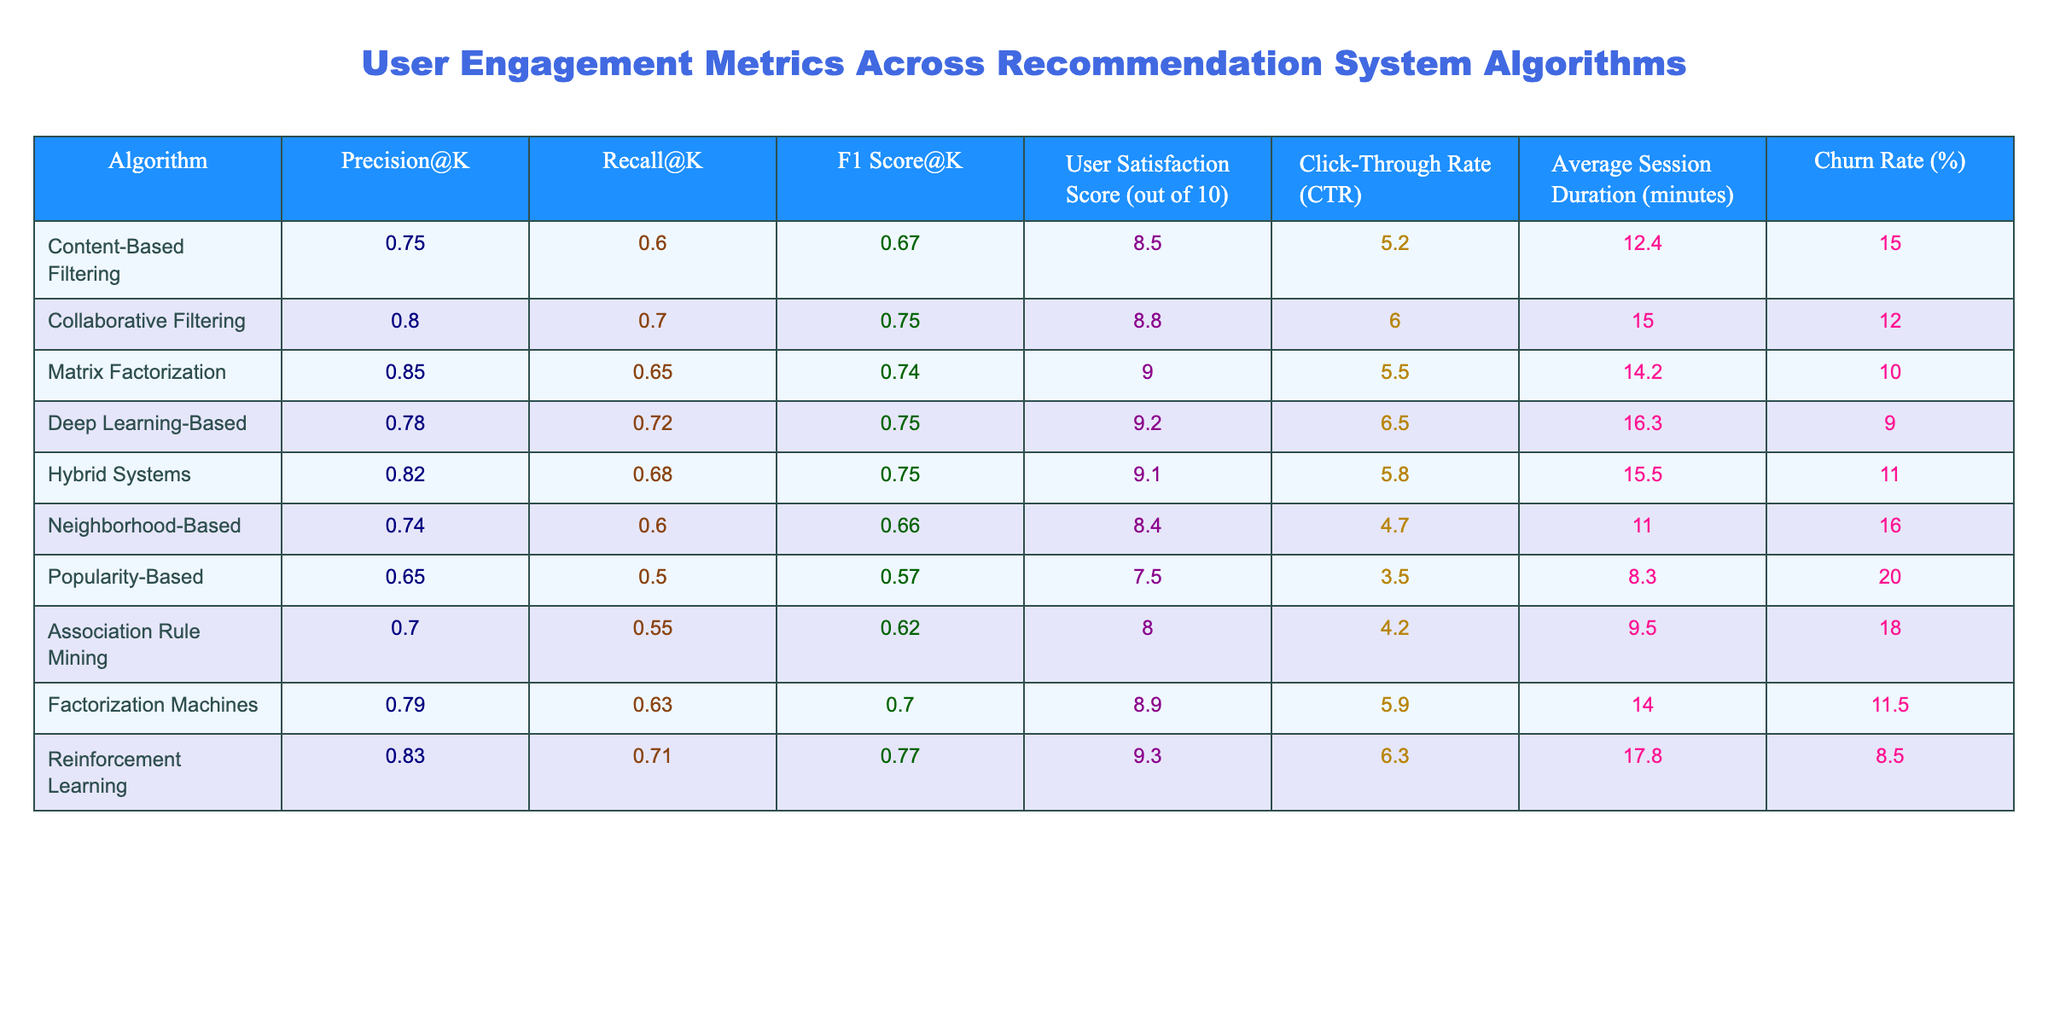What is the Precision@K of the Deep Learning-Based algorithm? The table shows that the Precision@K for the Deep Learning-Based algorithm is 0.78.
Answer: 0.78 Which algorithm has the highest Recall@K? The table indicates that the Matrix Factorization algorithm has the highest Recall@K value of 0.65.
Answer: Matrix Factorization What is the Average Session Duration for the Hybrid Systems? The table lists the Average Session Duration for Hybrid Systems as 15.5 minutes.
Answer: 15.5 minutes Which algorithm has the greatest User Satisfaction Score? Looking at the User Satisfaction Score column, the Deep Learning-Based algorithm, with a score of 9.2, has the highest value.
Answer: 9.2 What is the difference in Churn Rate between Popularity-Based and Neighborhood-Based algorithms? The Churn Rate for Popularity-Based is 20.0% and for Neighborhood-Based is 16.0%; therefore, the difference is 20.0% - 16.0% = 4.0%.
Answer: 4.0% Which two algorithms had a Recall@K greater than 0.70? The algorithms that fulfill this criterion are Collaborative Filtering (0.70) and Deep Learning-Based (0.72).
Answer: Collaborative Filtering and Deep Learning-Based What is the average User Satisfaction Score for all algorithms? To find the average, add all User Satisfaction Scores (8.5 + 8.8 + 9.0 + 9.2 + 9.1 + 8.4 + 7.5 + 8.0 + 8.9 + 9.3) and divide by the number of algorithms (10): (8.5 + 8.8 + 9.0 + 9.2 + 9.1 + 8.4 + 7.5 + 8.0 + 8.9 + 9.3) / 10 = 8.75.
Answer: 8.75 Is the Click-Through Rate higher for Hybrid Systems than for Collaborative Filtering? The Click-Through Rate for Hybrid Systems is 5.8%, while for Collaborative Filtering it's 6.0%, so Hybrid Systems have a lower Click-Through Rate.
Answer: No Which recommendation system algorithm has the lowest F1 Score@K and what is the value? Referring to the F1 Score@K column, the Popularity-Based algorithm has the lowest F1 Score at 0.57.
Answer: 0.57 If we filter for algorithms with a Churn Rate below 15%, which algorithms meet this criterion? The algorithms meeting this criterion are Matrix Factorization (10.0%), Deep Learning-Based (9.0%), and Reinforcement Learning (8.5%).
Answer: Matrix Factorization, Deep Learning-Based, and Reinforcement Learning 